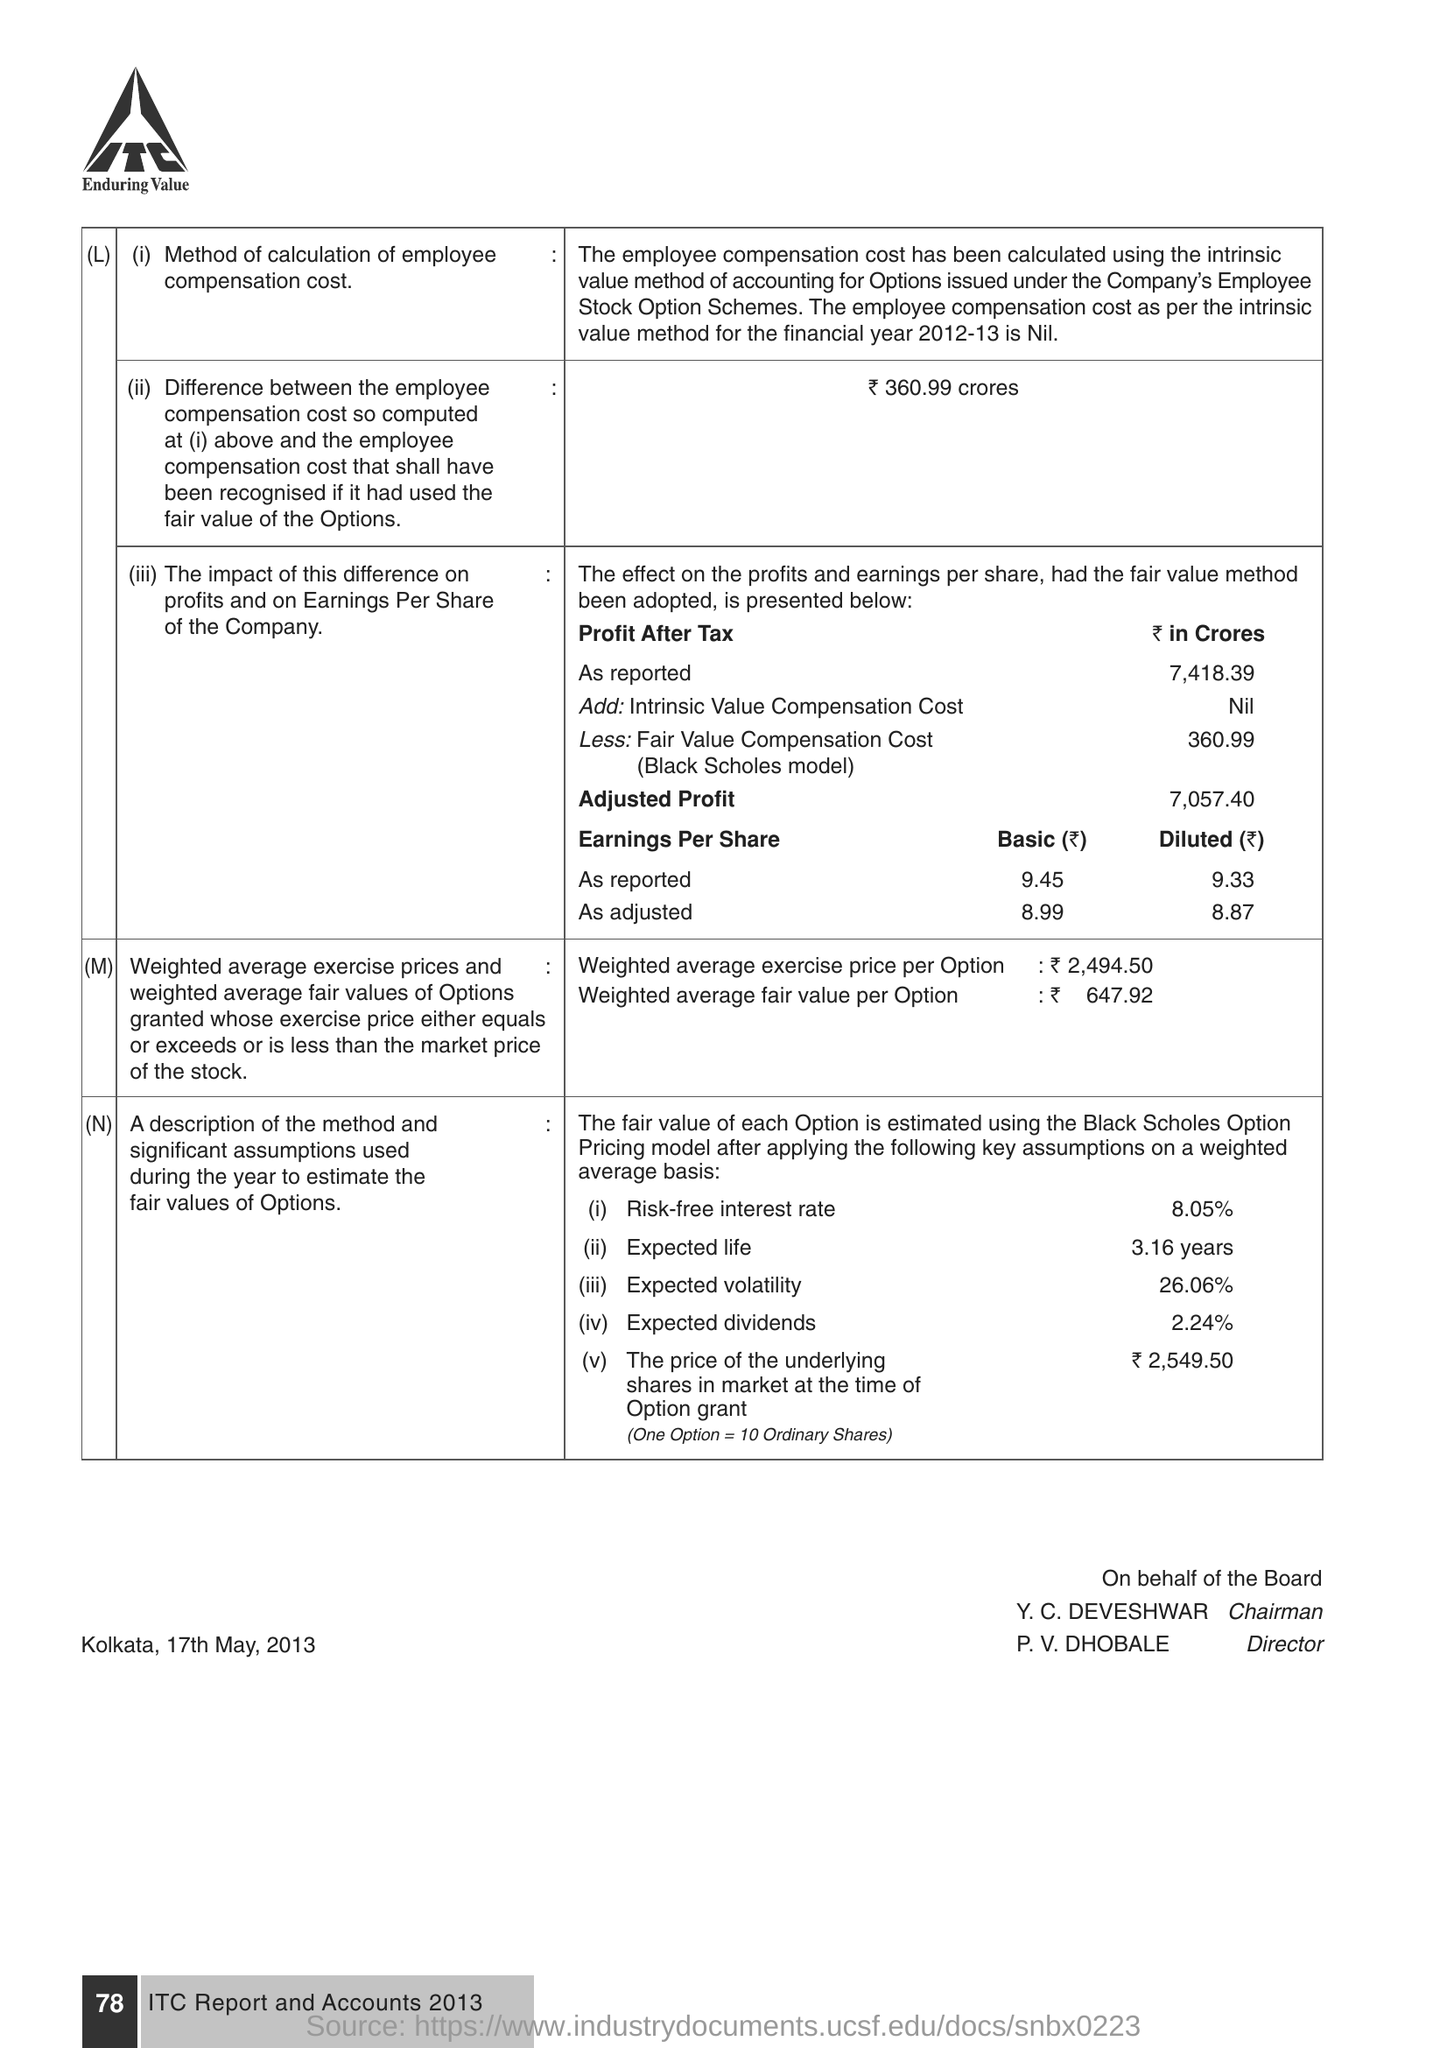List a handful of essential elements in this visual. The risk-free interest rate is 8.05%. The name of the chairman is Y. C. Deveshwar. The Director is P. V. Dhobale. 